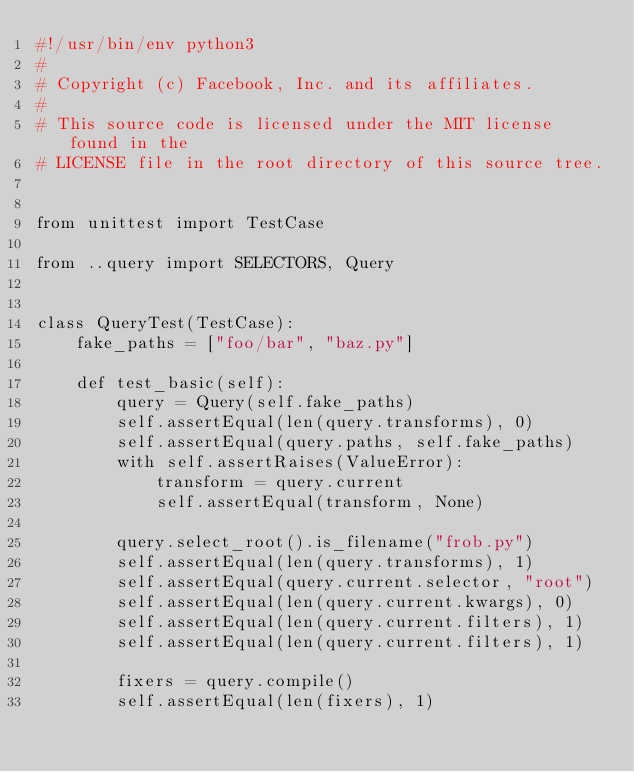Convert code to text. <code><loc_0><loc_0><loc_500><loc_500><_Python_>#!/usr/bin/env python3
#
# Copyright (c) Facebook, Inc. and its affiliates.
#
# This source code is licensed under the MIT license found in the
# LICENSE file in the root directory of this source tree.


from unittest import TestCase

from ..query import SELECTORS, Query


class QueryTest(TestCase):
    fake_paths = ["foo/bar", "baz.py"]

    def test_basic(self):
        query = Query(self.fake_paths)
        self.assertEqual(len(query.transforms), 0)
        self.assertEqual(query.paths, self.fake_paths)
        with self.assertRaises(ValueError):
            transform = query.current
            self.assertEqual(transform, None)

        query.select_root().is_filename("frob.py")
        self.assertEqual(len(query.transforms), 1)
        self.assertEqual(query.current.selector, "root")
        self.assertEqual(len(query.current.kwargs), 0)
        self.assertEqual(len(query.current.filters), 1)
        self.assertEqual(len(query.current.filters), 1)

        fixers = query.compile()
        self.assertEqual(len(fixers), 1)</code> 